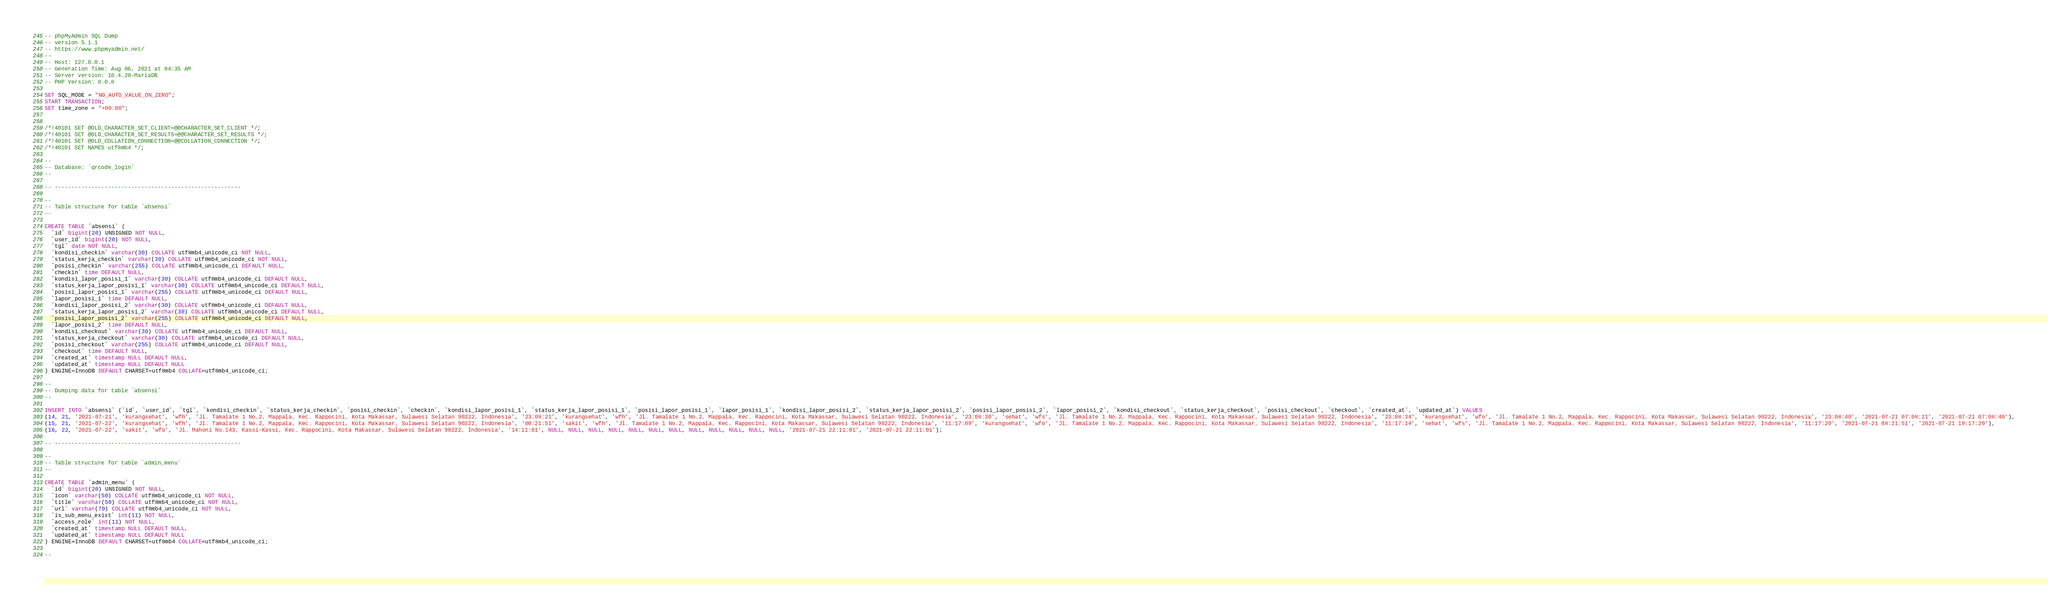<code> <loc_0><loc_0><loc_500><loc_500><_SQL_>-- phpMyAdmin SQL Dump
-- version 5.1.1
-- https://www.phpmyadmin.net/
--
-- Host: 127.0.0.1
-- Generation Time: Aug 06, 2021 at 04:35 AM
-- Server version: 10.4.20-MariaDB
-- PHP Version: 8.0.8

SET SQL_MODE = "NO_AUTO_VALUE_ON_ZERO";
START TRANSACTION;
SET time_zone = "+00:00";


/*!40101 SET @OLD_CHARACTER_SET_CLIENT=@@CHARACTER_SET_CLIENT */;
/*!40101 SET @OLD_CHARACTER_SET_RESULTS=@@CHARACTER_SET_RESULTS */;
/*!40101 SET @OLD_COLLATION_CONNECTION=@@COLLATION_CONNECTION */;
/*!40101 SET NAMES utf8mb4 */;

--
-- Database: `qrcode_login`
--

-- --------------------------------------------------------

--
-- Table structure for table `absensi`
--

CREATE TABLE `absensi` (
  `id` bigint(20) UNSIGNED NOT NULL,
  `user_id` bigint(20) NOT NULL,
  `tgl` date NOT NULL,
  `kondisi_checkin` varchar(30) COLLATE utf8mb4_unicode_ci NOT NULL,
  `status_kerja_checkin` varchar(30) COLLATE utf8mb4_unicode_ci NOT NULL,
  `posisi_checkin` varchar(255) COLLATE utf8mb4_unicode_ci DEFAULT NULL,
  `checkin` time DEFAULT NULL,
  `kondisi_lapor_posisi_1` varchar(30) COLLATE utf8mb4_unicode_ci DEFAULT NULL,
  `status_kerja_lapor_posisi_1` varchar(30) COLLATE utf8mb4_unicode_ci DEFAULT NULL,
  `posisi_lapor_posisi_1` varchar(255) COLLATE utf8mb4_unicode_ci DEFAULT NULL,
  `lapor_posisi_1` time DEFAULT NULL,
  `kondisi_lapor_posisi_2` varchar(30) COLLATE utf8mb4_unicode_ci DEFAULT NULL,
  `status_kerja_lapor_posisi_2` varchar(30) COLLATE utf8mb4_unicode_ci DEFAULT NULL,
  `posisi_lapor_posisi_2` varchar(255) COLLATE utf8mb4_unicode_ci DEFAULT NULL,
  `lapor_posisi_2` time DEFAULT NULL,
  `kondisi_checkout` varchar(30) COLLATE utf8mb4_unicode_ci DEFAULT NULL,
  `status_kerja_checkout` varchar(30) COLLATE utf8mb4_unicode_ci DEFAULT NULL,
  `posisi_checkout` varchar(255) COLLATE utf8mb4_unicode_ci DEFAULT NULL,
  `checkout` time DEFAULT NULL,
  `created_at` timestamp NULL DEFAULT NULL,
  `updated_at` timestamp NULL DEFAULT NULL
) ENGINE=InnoDB DEFAULT CHARSET=utf8mb4 COLLATE=utf8mb4_unicode_ci;

--
-- Dumping data for table `absensi`
--

INSERT INTO `absensi` (`id`, `user_id`, `tgl`, `kondisi_checkin`, `status_kerja_checkin`, `posisi_checkin`, `checkin`, `kondisi_lapor_posisi_1`, `status_kerja_lapor_posisi_1`, `posisi_lapor_posisi_1`, `lapor_posisi_1`, `kondisi_lapor_posisi_2`, `status_kerja_lapor_posisi_2`, `posisi_lapor_posisi_2`, `lapor_posisi_2`, `kondisi_checkout`, `status_kerja_checkout`, `posisi_checkout`, `checkout`, `created_at`, `updated_at`) VALUES
(14, 21, '2021-07-21', 'kurangsehat', 'wfh', 'Jl. Tamalate 1 No.2, Mappala, Kec. Rappocini, Kota Makassar, Sulawesi Selatan 90222, Indonesia', '23:08:21', 'kurangsehat', 'wfh', 'Jl. Tamalate 1 No.2, Mappala, Kec. Rappocini, Kota Makassar, Sulawesi Selatan 90222, Indonesia', '23:08:30', 'sehat', 'wfs', 'Jl. Tamalate 1 No.2, Mappala, Kec. Rappocini, Kota Makassar, Sulawesi Selatan 90222, Indonesia', '23:08:34', 'kurangsehat', 'wfo', 'Jl. Tamalate 1 No.2, Mappala, Kec. Rappocini, Kota Makassar, Sulawesi Selatan 90222, Indonesia', '23:08:40', '2021-07-21 07:08:21', '2021-07-21 07:08:40'),
(15, 21, '2021-07-22', 'kurangsehat', 'wfh', 'Jl. Tamalate 1 No.2, Mappala, Kec. Rappocini, Kota Makassar, Sulawesi Selatan 90222, Indonesia', '00:21:51', 'sakit', 'wfh', 'Jl. Tamalate 1 No.2, Mappala, Kec. Rappocini, Kota Makassar, Sulawesi Selatan 90222, Indonesia', '11:17:09', 'kurangsehat', 'wfo', 'Jl. Tamalate 1 No.2, Mappala, Kec. Rappocini, Kota Makassar, Sulawesi Selatan 90222, Indonesia', '11:17:14', 'sehat', 'wfs', 'Jl. Tamalate 1 No.2, Mappala, Kec. Rappocini, Kota Makassar, Sulawesi Selatan 90222, Indonesia', '11:17:20', '2021-07-21 08:21:51', '2021-07-21 19:17:20'),
(16, 22, '2021-07-22', 'sakit', 'wfo', 'Jl. Mahoni No.143, Kassi-Kassi, Kec. Rappocini, Kota Makassar, Sulawesi Selatan 90222, Indonesia', '14:11:01', NULL, NULL, NULL, NULL, NULL, NULL, NULL, NULL, NULL, NULL, NULL, NULL, '2021-07-21 22:11:01', '2021-07-21 22:11:01');

-- --------------------------------------------------------

--
-- Table structure for table `admin_menu`
--

CREATE TABLE `admin_menu` (
  `id` bigint(20) UNSIGNED NOT NULL,
  `icon` varchar(50) COLLATE utf8mb4_unicode_ci NOT NULL,
  `title` varchar(50) COLLATE utf8mb4_unicode_ci NOT NULL,
  `url` varchar(70) COLLATE utf8mb4_unicode_ci NOT NULL,
  `is_sub_menu_exist` int(11) NOT NULL,
  `access_role` int(11) NOT NULL,
  `created_at` timestamp NULL DEFAULT NULL,
  `updated_at` timestamp NULL DEFAULT NULL
) ENGINE=InnoDB DEFAULT CHARSET=utf8mb4 COLLATE=utf8mb4_unicode_ci;

--</code> 